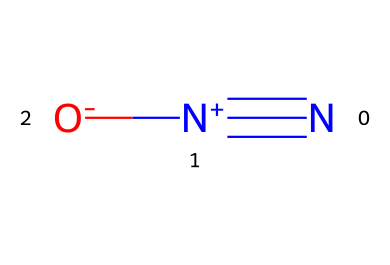What is the name of this chemical? The SMILES representation "N#[N+][O-]" identifies the compound as nitrous oxide. The "N" atoms and the "O" atom in this arrangement denote its structure and chemical properties.
Answer: nitrous oxide How many nitrogen atoms are present in this molecule? The SMILES notation indicates two nitrogen atoms (N) connected by a triple bond. Count the "N" occurrences to determine the total.
Answer: 2 What type of bond is formed between the nitrogen atoms? The structure shows a "#" symbol between the two "N" atoms, which indicates a triple bond. This is a characteristic feature of certain diatomic compounds like nitrous oxide.
Answer: triple bond What is the charge of the nitrogen on the right side? In the SMILES representation, the nitrogen on the right has a plus sign "[N+]" indicating it carries a positive charge. This defines the oxidation state of that nitrogen in the molecule.
Answer: positive How many total atoms are in this molecule? Counting all atoms in "N#[N+][O-]", we have two nitrogen atoms and one oxygen atom, summing them gives three total atoms present in nitrous oxide.
Answer: 3 What is the charge of the oxygen atom? The SMILES indicates the oxygen atom has a minus sign "[O-]", which signifies that it carries a negative charge. This is a distinguishing factor of the molecule's behavior.
Answer: negative What type of gas is nitrous oxide at room temperature? Nitrous oxide (N2O) is classified as a gas under standard temperature and pressure conditions. Its physical state is determined from common knowledge of atmospheric gases.
Answer: gas 